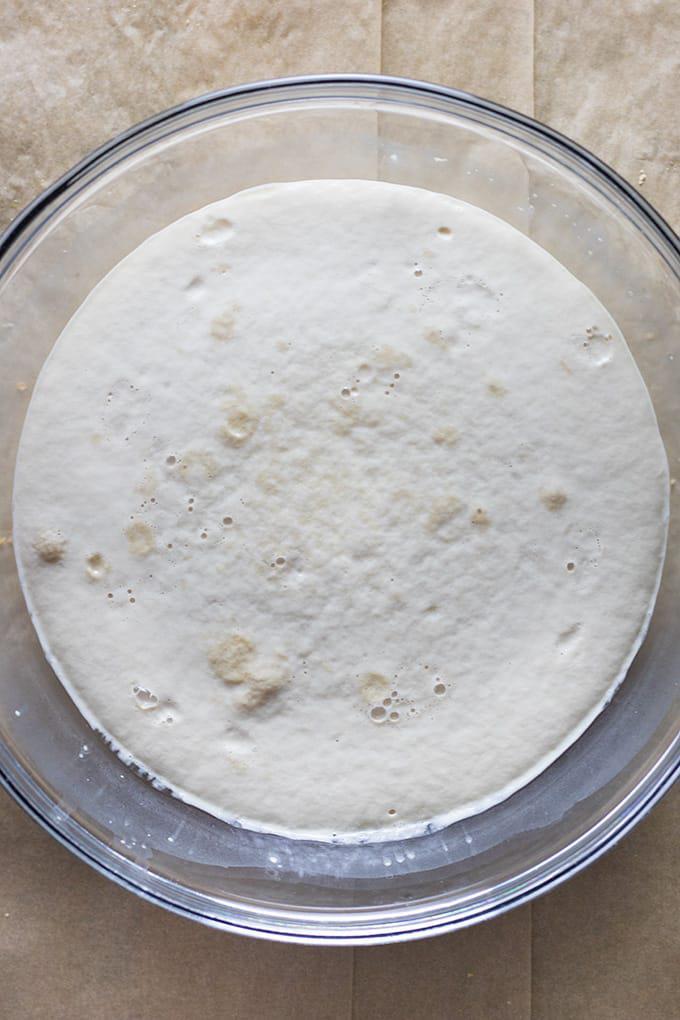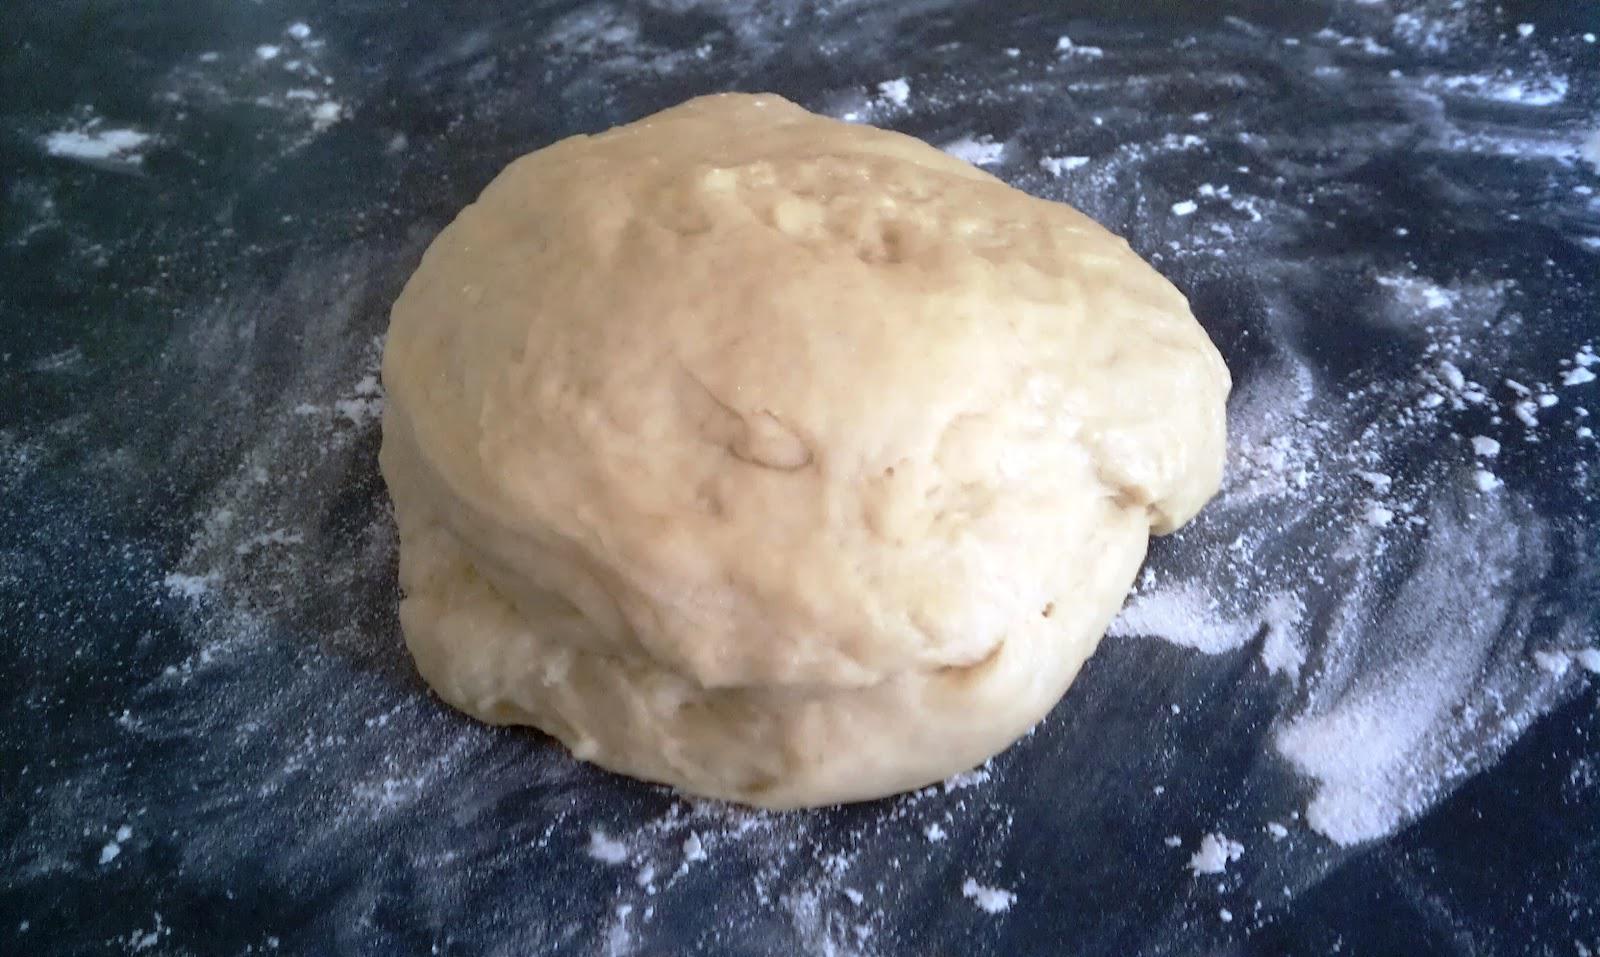The first image is the image on the left, the second image is the image on the right. Examine the images to the left and right. Is the description "Some of the dough is still in the mixing bowl." accurate? Answer yes or no. Yes. 